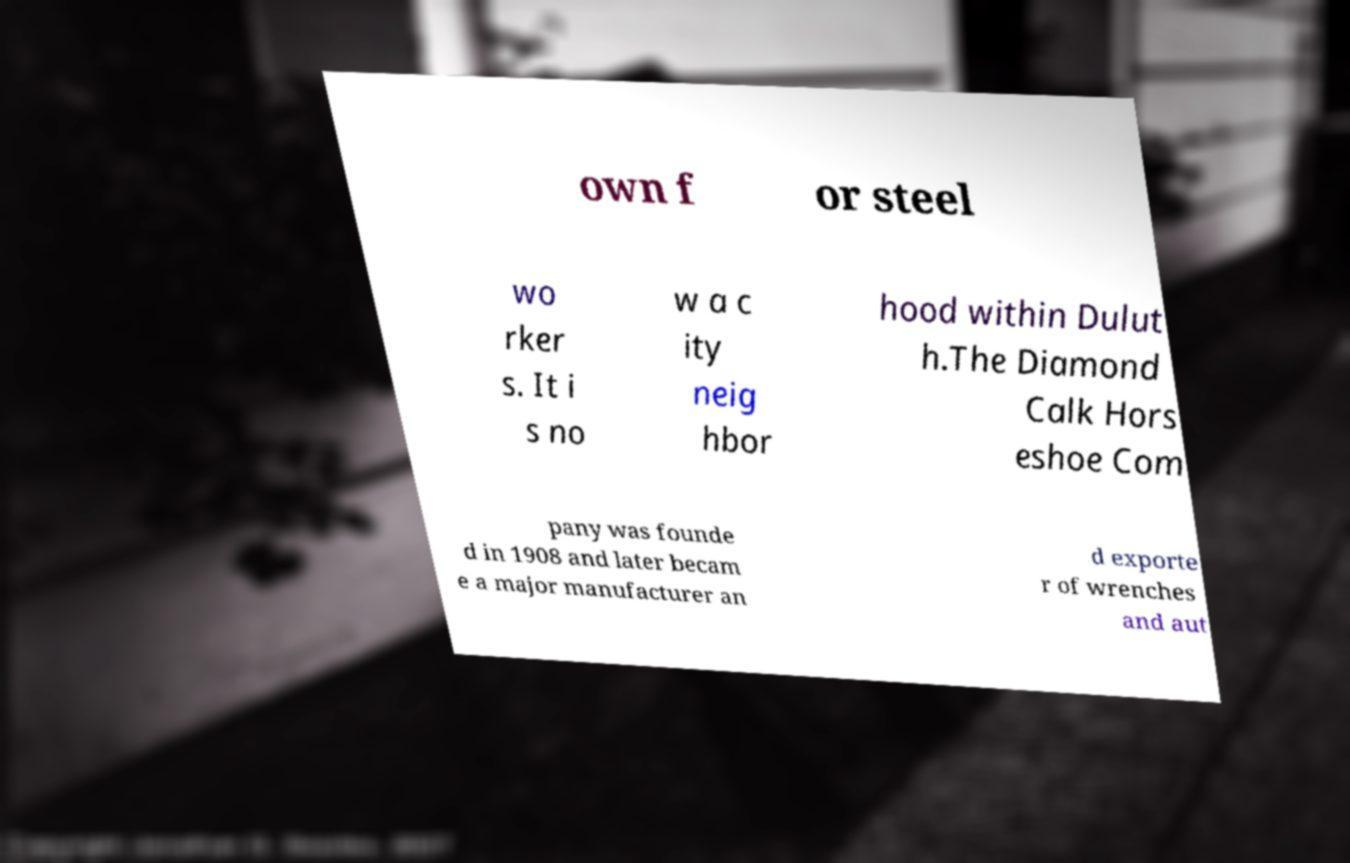I need the written content from this picture converted into text. Can you do that? own f or steel wo rker s. It i s no w a c ity neig hbor hood within Dulut h.The Diamond Calk Hors eshoe Com pany was founde d in 1908 and later becam e a major manufacturer an d exporte r of wrenches and aut 